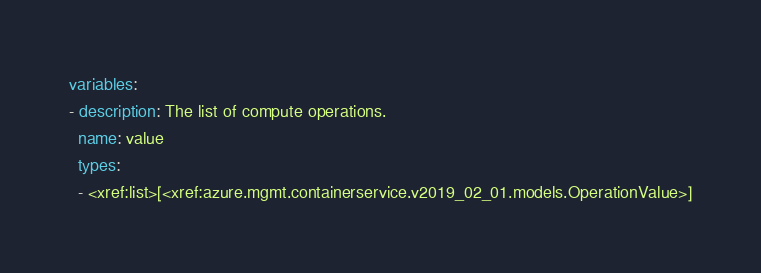<code> <loc_0><loc_0><loc_500><loc_500><_YAML_>variables:
- description: The list of compute operations.
  name: value
  types:
  - <xref:list>[<xref:azure.mgmt.containerservice.v2019_02_01.models.OperationValue>]
</code> 